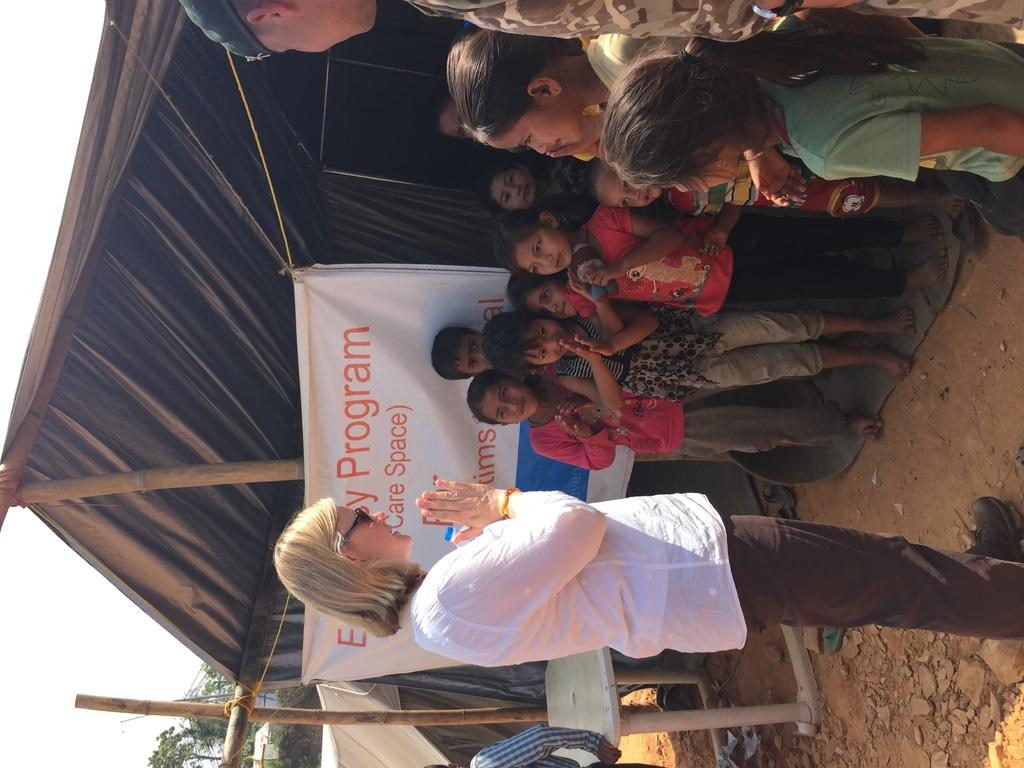Who is present in the image with the children? There is a woman standing near the children in the image. What is the man in the image doing? The man is standing at a table in the image. What can be seen in the background of the image? There is a tent and the sky visible in the background of the image. What type of wool is being used by the class in the image? There is no class or wool present in the image. Can you describe the cub that is playing with the children in the image? There is no cub present in the image; only a woman, children, and a man are visible. 